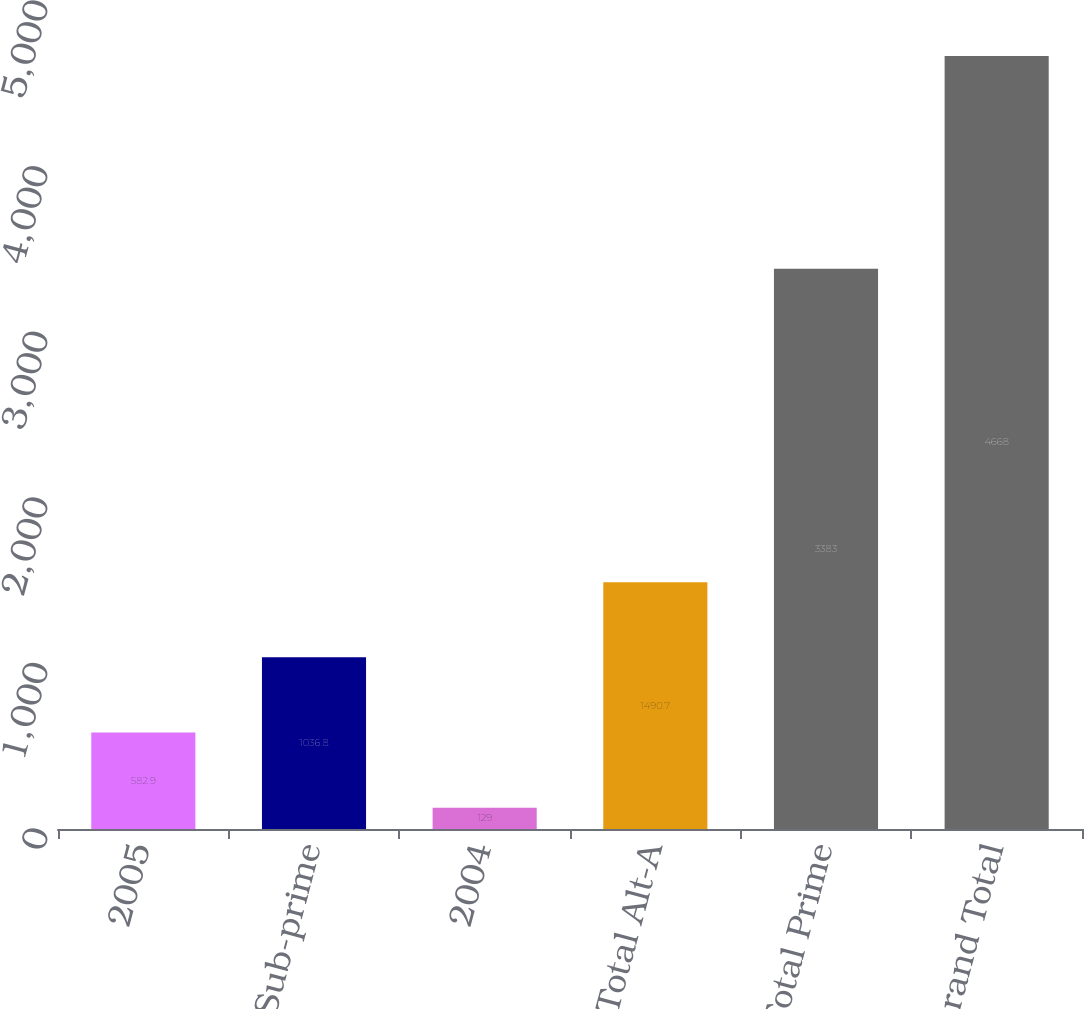<chart> <loc_0><loc_0><loc_500><loc_500><bar_chart><fcel>2005<fcel>Total Sub-prime<fcel>2004<fcel>Total Alt-A<fcel>Total Prime<fcel>Grand Total<nl><fcel>582.9<fcel>1036.8<fcel>129<fcel>1490.7<fcel>3383<fcel>4668<nl></chart> 